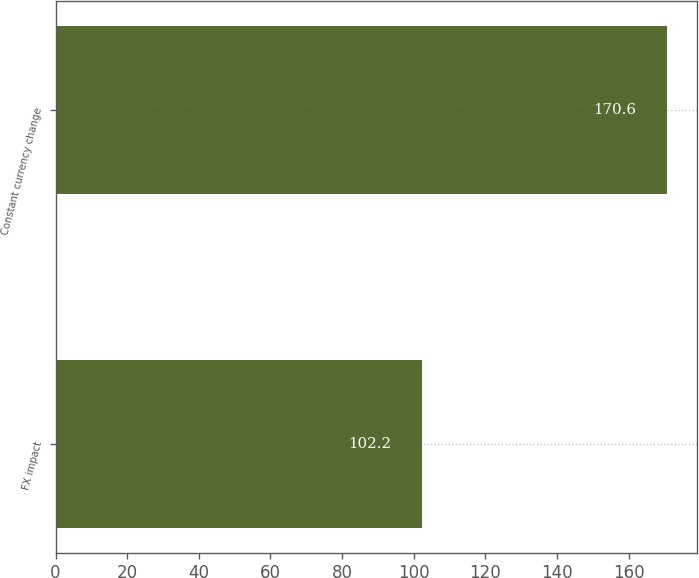Convert chart. <chart><loc_0><loc_0><loc_500><loc_500><bar_chart><fcel>FX impact<fcel>Constant currency change<nl><fcel>102.2<fcel>170.6<nl></chart> 